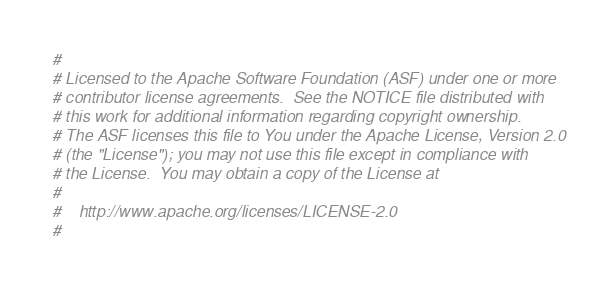<code> <loc_0><loc_0><loc_500><loc_500><_Python_>#
# Licensed to the Apache Software Foundation (ASF) under one or more
# contributor license agreements.  See the NOTICE file distributed with
# this work for additional information regarding copyright ownership.
# The ASF licenses this file to You under the Apache License, Version 2.0
# (the "License"); you may not use this file except in compliance with
# the License.  You may obtain a copy of the License at
#
#    http://www.apache.org/licenses/LICENSE-2.0
#</code> 